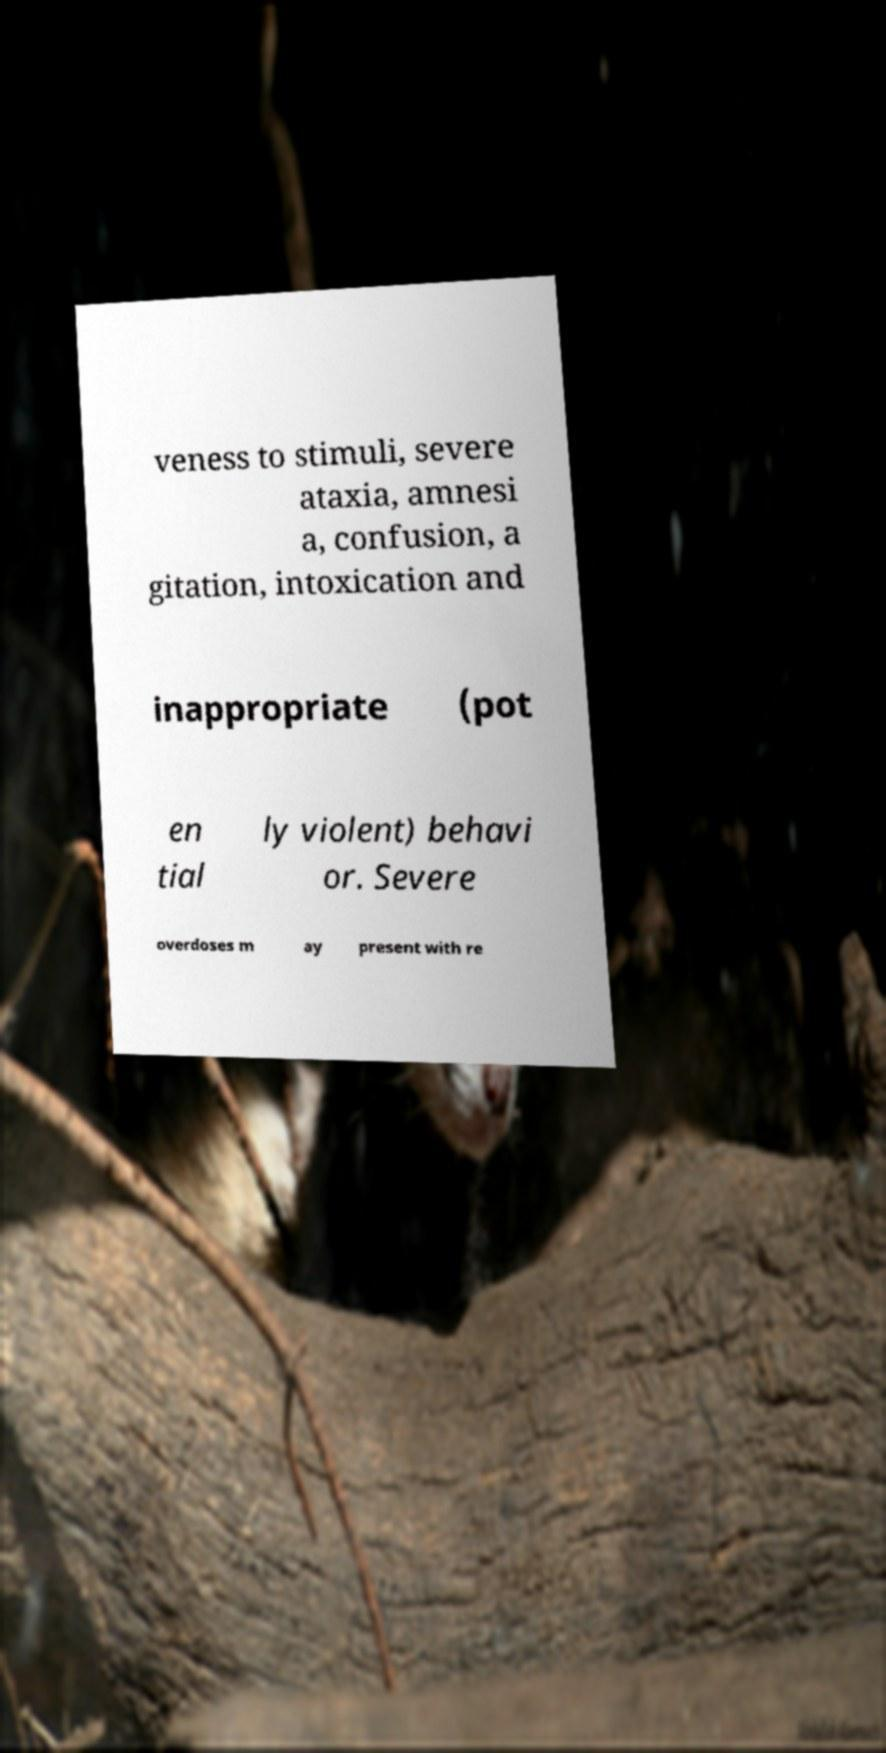Could you extract and type out the text from this image? veness to stimuli, severe ataxia, amnesi a, confusion, a gitation, intoxication and inappropriate (pot en tial ly violent) behavi or. Severe overdoses m ay present with re 